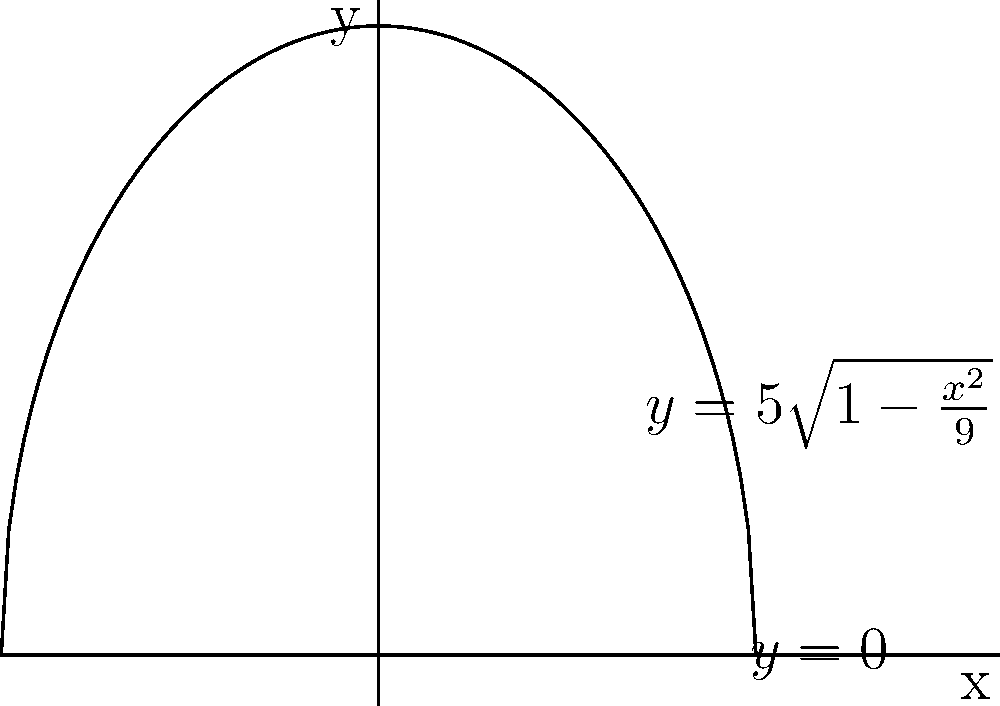A traditional Tongan kava bowl is shaped like a hemisphere. The cross-section of the bowl can be represented by the function $y = 5\sqrt{1-\frac{x^2}{9}}$ from $x=-3$ to $x=3$. Calculate the volume of the kava bowl using the washer method. To find the volume using the washer method, we follow these steps:

1) The washer method formula is: $V = \pi \int_a^b [R(x)^2 - r(x)^2] dx$

   Where $R(x)$ is the outer radius and $r(x)$ is the inner radius.

2) In this case, $R(x) = 5\sqrt{1-\frac{x^2}{9}}$ and $r(x) = 0$

3) Substituting into the formula:
   $V = \pi \int_{-3}^3 [(5\sqrt{1-\frac{x^2}{9}})^2 - 0^2] dx$

4) Simplify:
   $V = \pi \int_{-3}^3 25(1-\frac{x^2}{9}) dx$

5) Expand:
   $V = 25\pi \int_{-3}^3 (1-\frac{x^2}{9}) dx$

6) Integrate:
   $V = 25\pi [x - \frac{x^3}{27}]_{-3}^3$

7) Evaluate the bounds:
   $V = 25\pi [(3 - \frac{27}{27}) - (-3 - \frac{-27}{27})]$
   $V = 25\pi [2 - (-2)]$
   $V = 25\pi [4]$

8) Calculate the final result:
   $V = 100\pi$ cubic units

Therefore, the volume of the Tongan kava bowl is $100\pi$ cubic units.
Answer: $100\pi$ cubic units 